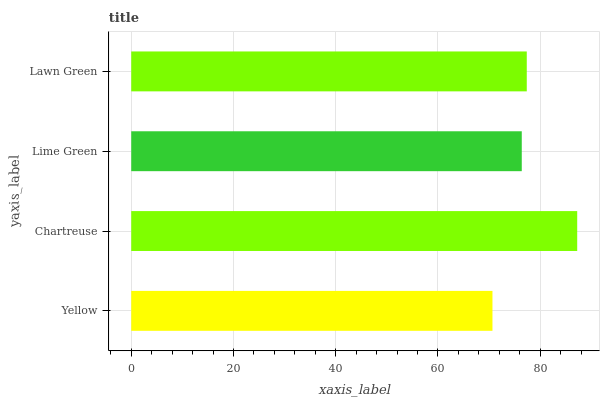Is Yellow the minimum?
Answer yes or no. Yes. Is Chartreuse the maximum?
Answer yes or no. Yes. Is Lime Green the minimum?
Answer yes or no. No. Is Lime Green the maximum?
Answer yes or no. No. Is Chartreuse greater than Lime Green?
Answer yes or no. Yes. Is Lime Green less than Chartreuse?
Answer yes or no. Yes. Is Lime Green greater than Chartreuse?
Answer yes or no. No. Is Chartreuse less than Lime Green?
Answer yes or no. No. Is Lawn Green the high median?
Answer yes or no. Yes. Is Lime Green the low median?
Answer yes or no. Yes. Is Lime Green the high median?
Answer yes or no. No. Is Chartreuse the low median?
Answer yes or no. No. 